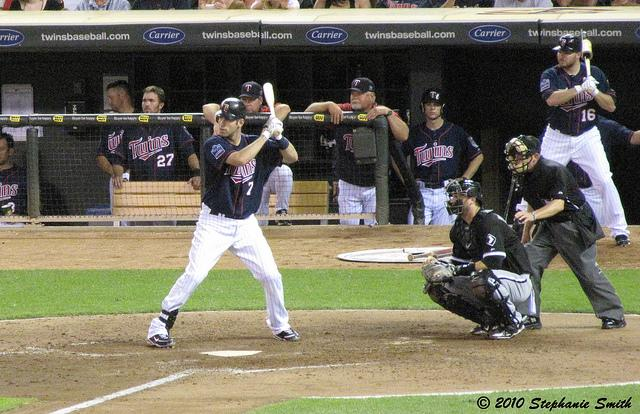What league does the team with the standing players play in? mlb 